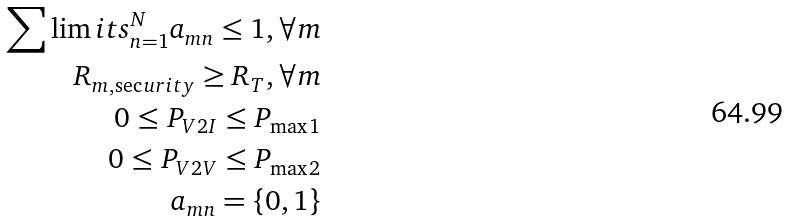Convert formula to latex. <formula><loc_0><loc_0><loc_500><loc_500>\sum \lim i t s _ { n = 1 } ^ { N } { { a _ { m n } } \leq 1 } , \forall m \\ { R _ { m , \sec u r i t y } } \geq { R _ { T } } , \forall m \\ 0 \leq { P _ { V 2 I } } \leq { P _ { \max 1 } } \\ 0 \leq { P _ { V 2 V } } \leq { P _ { \max 2 } } \\ { a _ { m n } } = \{ 0 , 1 \}</formula> 